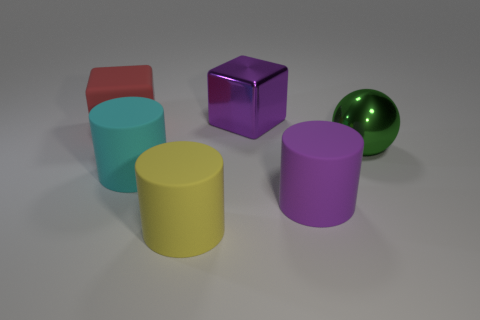Add 3 large yellow rubber things. How many objects exist? 9 Subtract all cubes. How many objects are left? 4 Subtract all green rubber cubes. Subtract all big matte cubes. How many objects are left? 5 Add 2 rubber cylinders. How many rubber cylinders are left? 5 Add 4 cyan matte cylinders. How many cyan matte cylinders exist? 5 Subtract 0 brown cylinders. How many objects are left? 6 